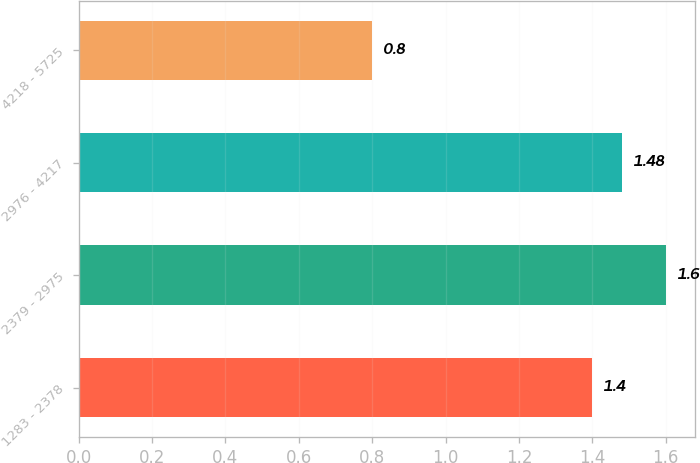Convert chart. <chart><loc_0><loc_0><loc_500><loc_500><bar_chart><fcel>1283 - 2378<fcel>2379 - 2975<fcel>2976 - 4217<fcel>4218 - 5725<nl><fcel>1.4<fcel>1.6<fcel>1.48<fcel>0.8<nl></chart> 